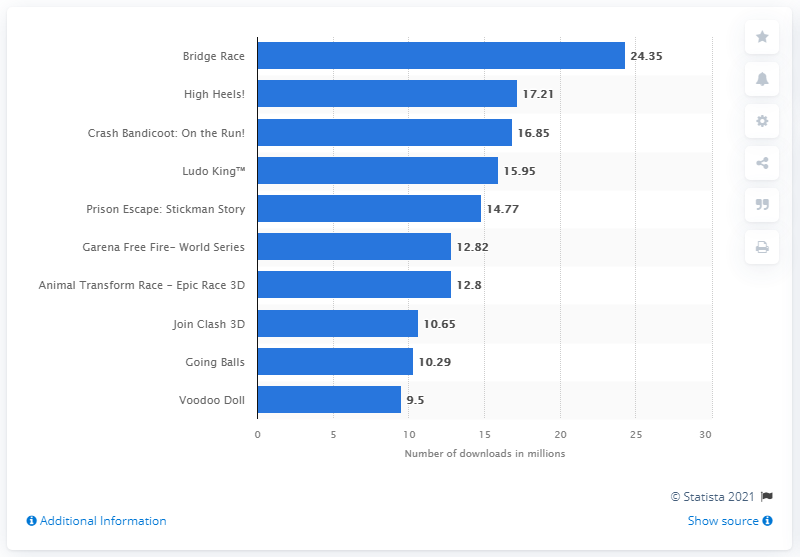Mention a couple of crucial points in this snapshot. The number of downloads of Bridge Race from Android users was 24.35. High Heels! received 17.21 downloads from global users. According to data from the Google Play Store in April 2021, the most downloaded game was Bridge Race. The second most popular gaming app title was "High Heels. 